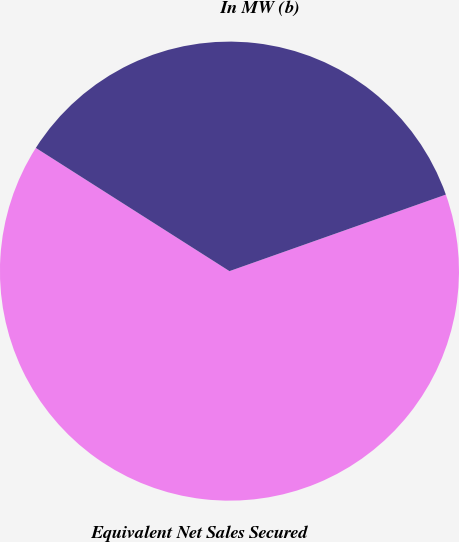Convert chart to OTSL. <chart><loc_0><loc_0><loc_500><loc_500><pie_chart><fcel>Equivalent Net Sales Secured<fcel>In MW (b)<nl><fcel>64.43%<fcel>35.57%<nl></chart> 